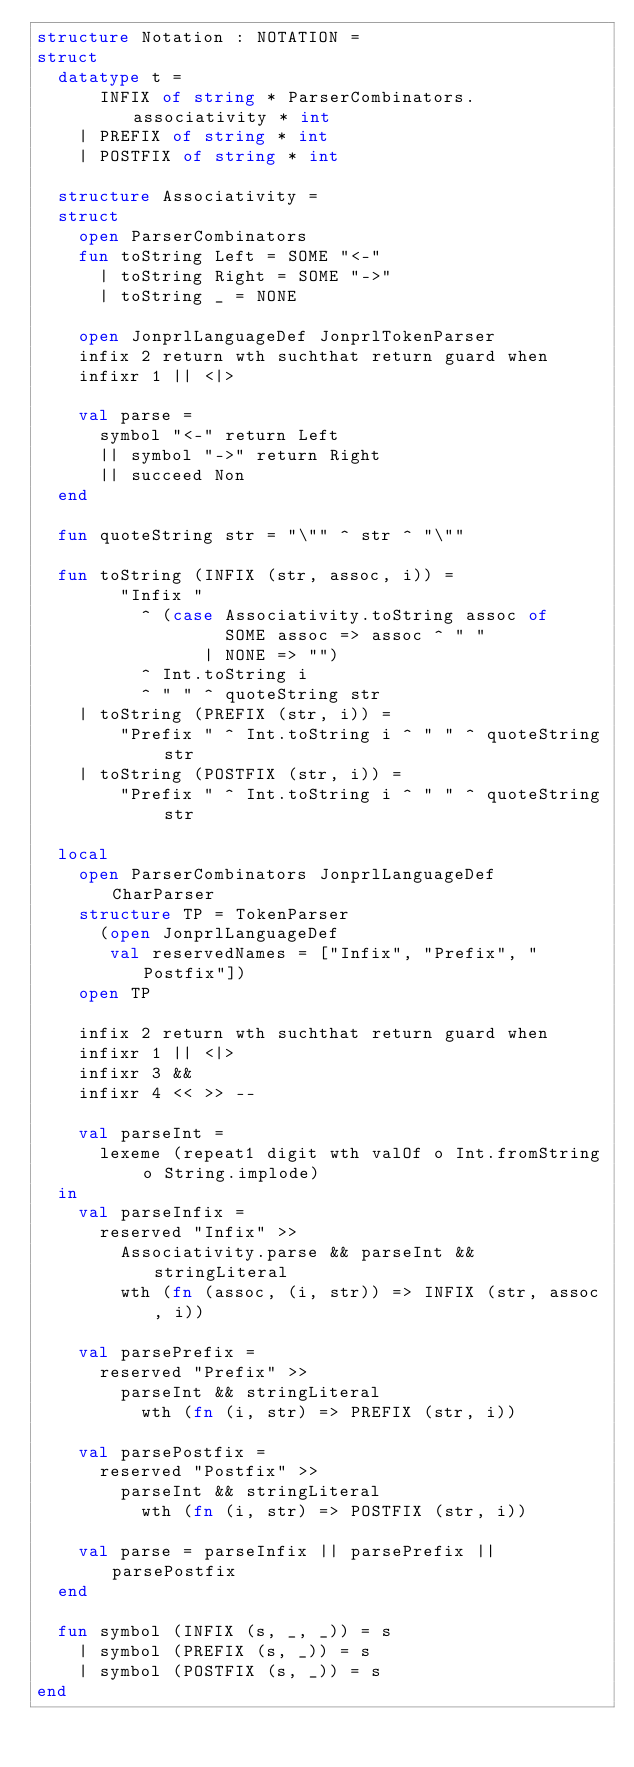Convert code to text. <code><loc_0><loc_0><loc_500><loc_500><_SML_>structure Notation : NOTATION =
struct
  datatype t =
      INFIX of string * ParserCombinators.associativity * int
    | PREFIX of string * int
    | POSTFIX of string * int

  structure Associativity =
  struct
    open ParserCombinators
    fun toString Left = SOME "<-"
      | toString Right = SOME "->"
      | toString _ = NONE

    open JonprlLanguageDef JonprlTokenParser
    infix 2 return wth suchthat return guard when
    infixr 1 || <|>

    val parse =
      symbol "<-" return Left
      || symbol "->" return Right
      || succeed Non
  end

  fun quoteString str = "\"" ^ str ^ "\""

  fun toString (INFIX (str, assoc, i)) =
        "Infix "
          ^ (case Associativity.toString assoc of
                  SOME assoc => assoc ^ " "
                | NONE => "")
          ^ Int.toString i
          ^ " " ^ quoteString str
    | toString (PREFIX (str, i)) =
        "Prefix " ^ Int.toString i ^ " " ^ quoteString str
    | toString (POSTFIX (str, i)) =
        "Prefix " ^ Int.toString i ^ " " ^ quoteString str

  local
    open ParserCombinators JonprlLanguageDef CharParser
    structure TP = TokenParser
      (open JonprlLanguageDef
       val reservedNames = ["Infix", "Prefix", "Postfix"])
    open TP

    infix 2 return wth suchthat return guard when
    infixr 1 || <|>
    infixr 3 &&
    infixr 4 << >> --

    val parseInt =
      lexeme (repeat1 digit wth valOf o Int.fromString o String.implode)
  in
    val parseInfix =
      reserved "Infix" >>
        Associativity.parse && parseInt && stringLiteral
        wth (fn (assoc, (i, str)) => INFIX (str, assoc, i))

    val parsePrefix =
      reserved "Prefix" >>
        parseInt && stringLiteral
          wth (fn (i, str) => PREFIX (str, i))

    val parsePostfix =
      reserved "Postfix" >>
        parseInt && stringLiteral
          wth (fn (i, str) => POSTFIX (str, i))

    val parse = parseInfix || parsePrefix || parsePostfix
  end

  fun symbol (INFIX (s, _, _)) = s
    | symbol (PREFIX (s, _)) = s
    | symbol (POSTFIX (s, _)) = s
end
</code> 